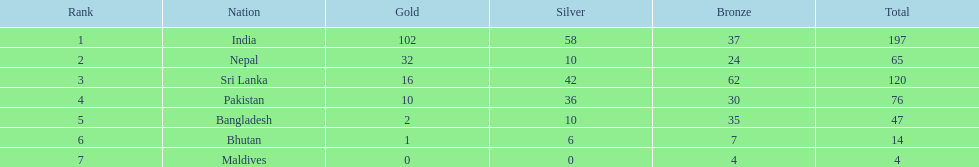What is the disparity in medal count between the country with the most and the country with the least number of medals? 193. 